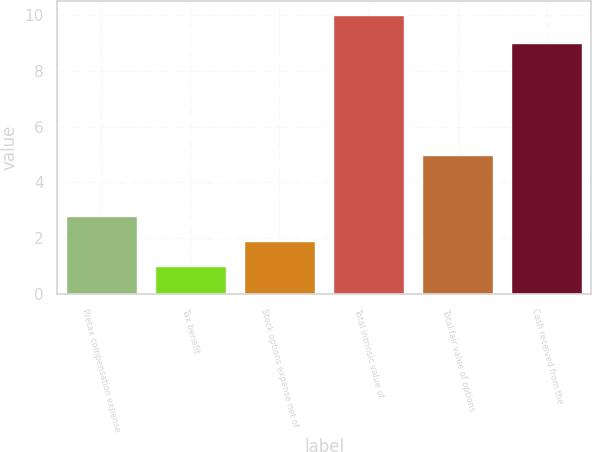<chart> <loc_0><loc_0><loc_500><loc_500><bar_chart><fcel>Pretax compensation expense<fcel>Tax benefit<fcel>Stock options expense net of<fcel>Total intrinsic value of<fcel>Total fair value of options<fcel>Cash received from the<nl><fcel>2.8<fcel>1<fcel>1.9<fcel>10<fcel>5<fcel>9<nl></chart> 